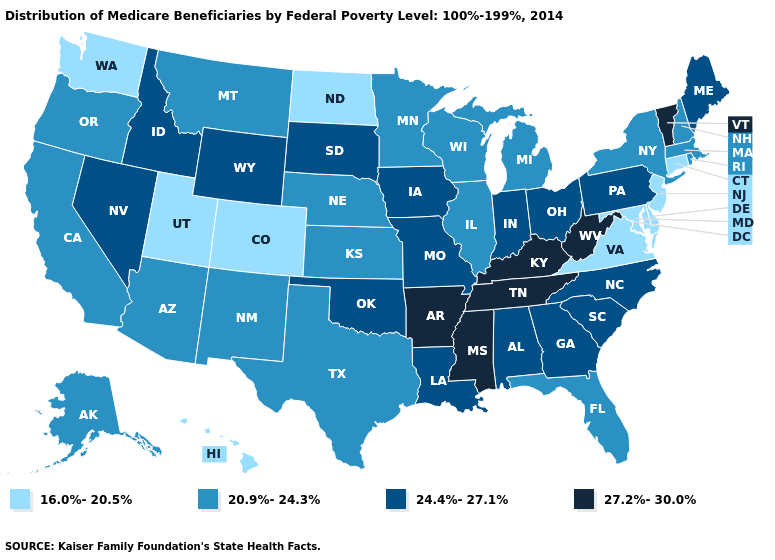What is the lowest value in states that border Utah?
Write a very short answer. 16.0%-20.5%. Name the states that have a value in the range 20.9%-24.3%?
Short answer required. Alaska, Arizona, California, Florida, Illinois, Kansas, Massachusetts, Michigan, Minnesota, Montana, Nebraska, New Hampshire, New Mexico, New York, Oregon, Rhode Island, Texas, Wisconsin. Which states have the lowest value in the USA?
Give a very brief answer. Colorado, Connecticut, Delaware, Hawaii, Maryland, New Jersey, North Dakota, Utah, Virginia, Washington. What is the highest value in the Northeast ?
Write a very short answer. 27.2%-30.0%. Is the legend a continuous bar?
Write a very short answer. No. Does West Virginia have a lower value than North Dakota?
Short answer required. No. What is the value of Hawaii?
Concise answer only. 16.0%-20.5%. Which states have the lowest value in the Northeast?
Concise answer only. Connecticut, New Jersey. What is the value of New Hampshire?
Quick response, please. 20.9%-24.3%. Does Massachusetts have the lowest value in the USA?
Keep it brief. No. Does West Virginia have the highest value in the USA?
Concise answer only. Yes. Does the map have missing data?
Be succinct. No. What is the value of North Carolina?
Write a very short answer. 24.4%-27.1%. Does Texas have a lower value than Tennessee?
Quick response, please. Yes. Name the states that have a value in the range 20.9%-24.3%?
Keep it brief. Alaska, Arizona, California, Florida, Illinois, Kansas, Massachusetts, Michigan, Minnesota, Montana, Nebraska, New Hampshire, New Mexico, New York, Oregon, Rhode Island, Texas, Wisconsin. 